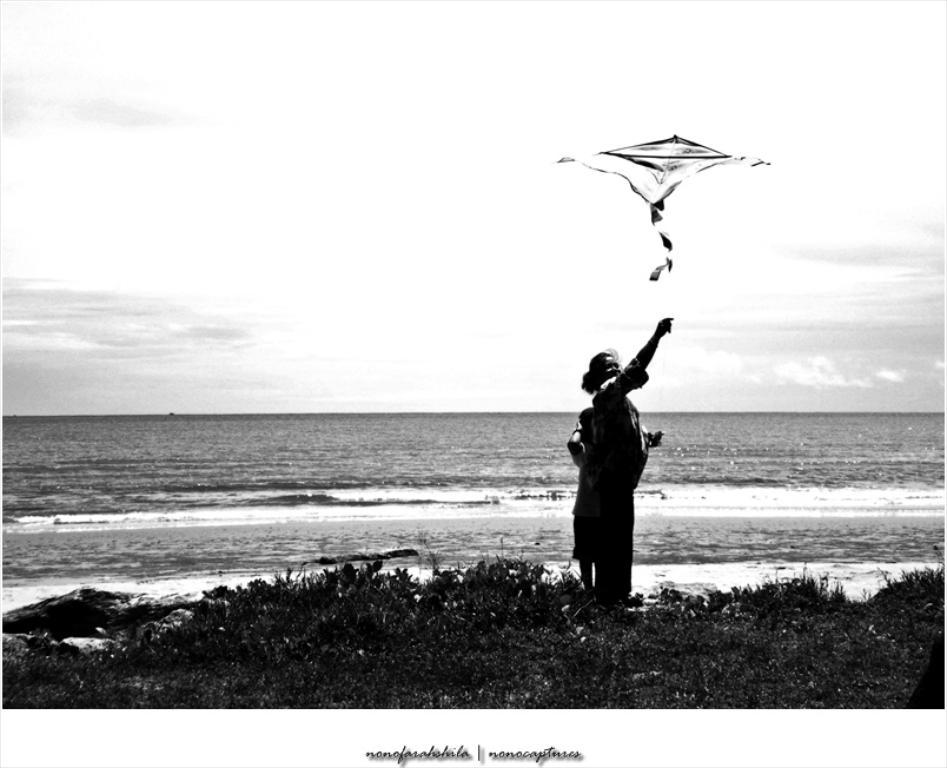What is flying in the air in the image? There is a kite flying in the air in the image. What type of natural elements can be seen in the image? Plants and water are visible in the image. How many people are present in the image? There are two people standing on the ground in the image. What is visible in the background of the image? The sky with clouds is visible in the background of the image. What type of plastic objects can be seen attacking the kite in the image? There are no plastic objects or any indication of an attack present in the image. 